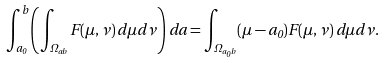Convert formula to latex. <formula><loc_0><loc_0><loc_500><loc_500>\int _ { a _ { 0 } } ^ { b } \left ( \int _ { \Omega _ { a b } } F ( \mu , \nu ) \, d \mu d \nu \right ) \, d a = \int _ { \Omega _ { a _ { 0 } b } } ( \mu - a _ { 0 } ) F ( \mu , \nu ) \, d \mu d \nu .</formula> 